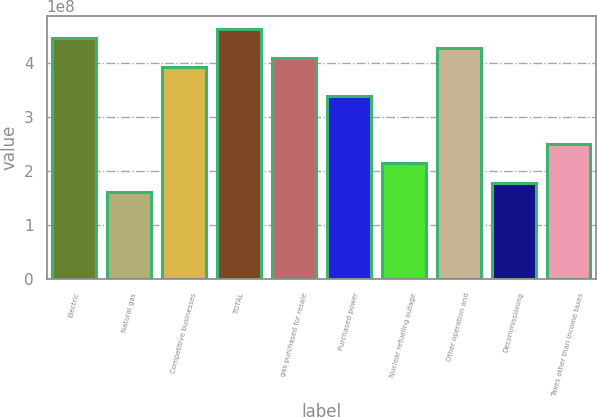<chart> <loc_0><loc_0><loc_500><loc_500><bar_chart><fcel>Electric<fcel>Natural gas<fcel>Competitive businesses<fcel>TOTAL<fcel>gas purchased for resale<fcel>Purchased power<fcel>Nuclear refueling outage<fcel>Other operation and<fcel>Decommissioning<fcel>Taxes other than income taxes<nl><fcel>4.45927e+08<fcel>1.60534e+08<fcel>3.92416e+08<fcel>4.63764e+08<fcel>4.10253e+08<fcel>3.38904e+08<fcel>2.14045e+08<fcel>4.2809e+08<fcel>1.78371e+08<fcel>2.49719e+08<nl></chart> 